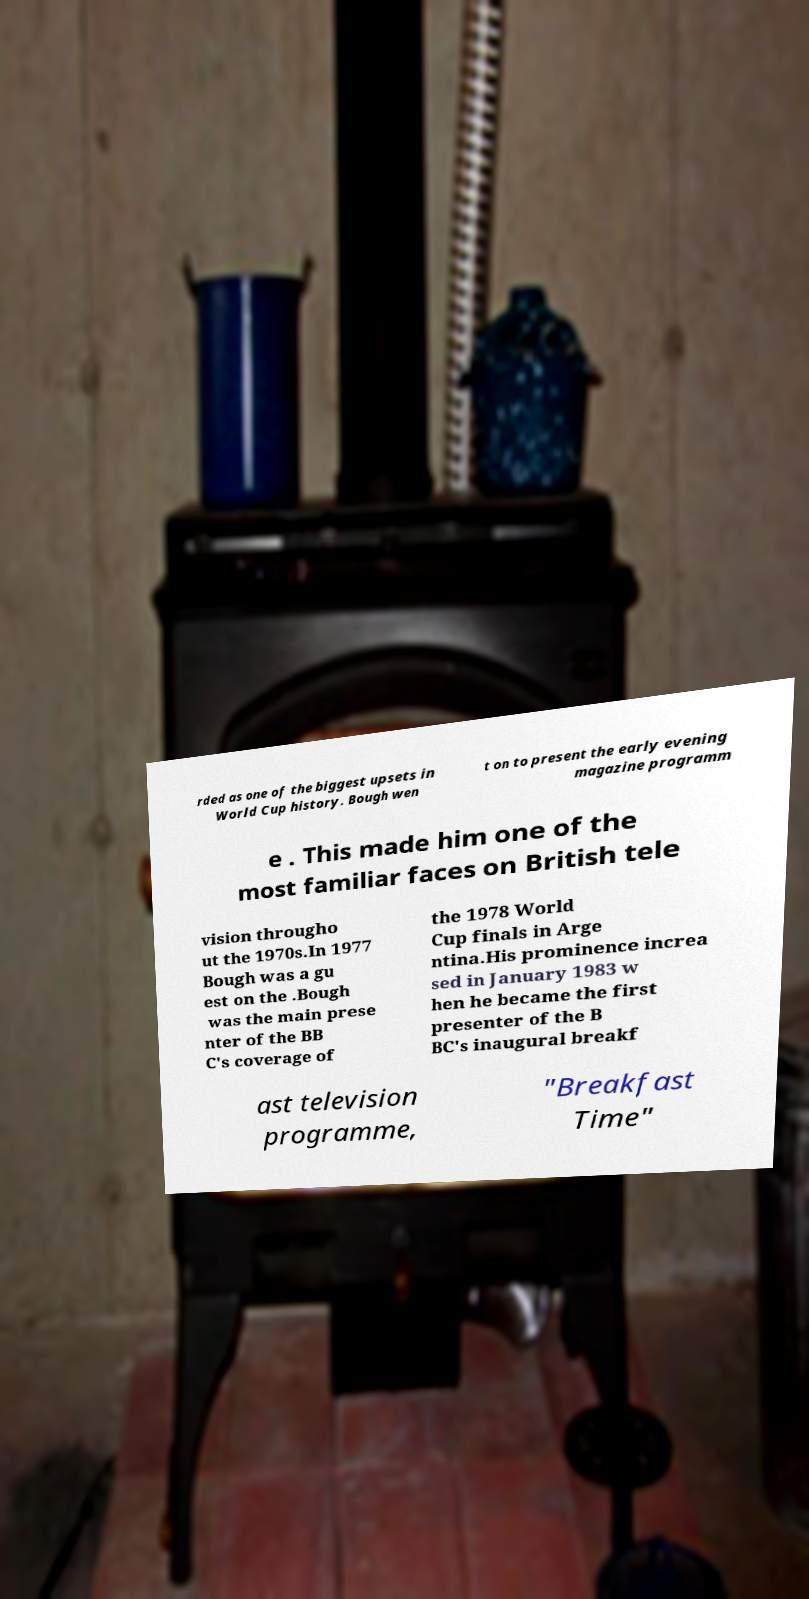Can you accurately transcribe the text from the provided image for me? rded as one of the biggest upsets in World Cup history. Bough wen t on to present the early evening magazine programm e . This made him one of the most familiar faces on British tele vision througho ut the 1970s.In 1977 Bough was a gu est on the .Bough was the main prese nter of the BB C's coverage of the 1978 World Cup finals in Arge ntina.His prominence increa sed in January 1983 w hen he became the first presenter of the B BC's inaugural breakf ast television programme, "Breakfast Time" 